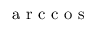<formula> <loc_0><loc_0><loc_500><loc_500>a r c c o s</formula> 